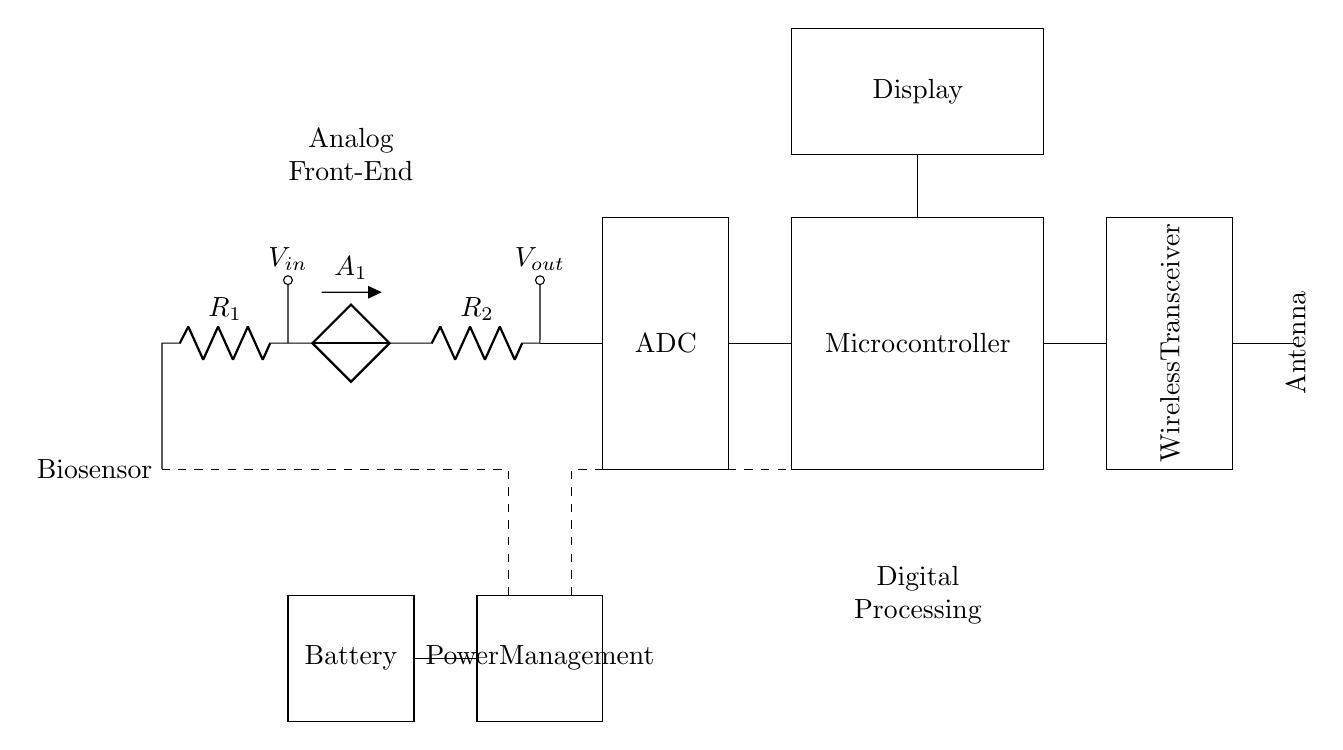What type of circuit is depicted? The circuit is a hybrid design, incorporating both analog and digital components for a health monitoring application.
Answer: hybrid What does the ADC do in the circuit? The ADC converts the analog voltage output from the biosensor into a digital signal for processing by the microcontroller.
Answer: converts voltage What component is used for power management? The circuit includes a power management module which regulates power supply from the battery to the other components.
Answer: Power Management What is the primary function of the microcontroller? The microcontroller processes the digital data received from the ADC and executes the required tasks based on that data.
Answer: data processing How many resistors are present in the circuit? There are two resistors labeled R1 and R2 in the analog section of the circuit.
Answer: two What is the relationship between the input and output voltage? The output voltage is determined by the voltage divider effect due to the resistors R1 and R2 connected in series with the biosensor.
Answer: voltage divider effect What is the purpose of wireless transceiver in this design? The wireless transceiver enables the device to communicate data wirelessly to a paired device for further analysis or monitoring.
Answer: data communication 